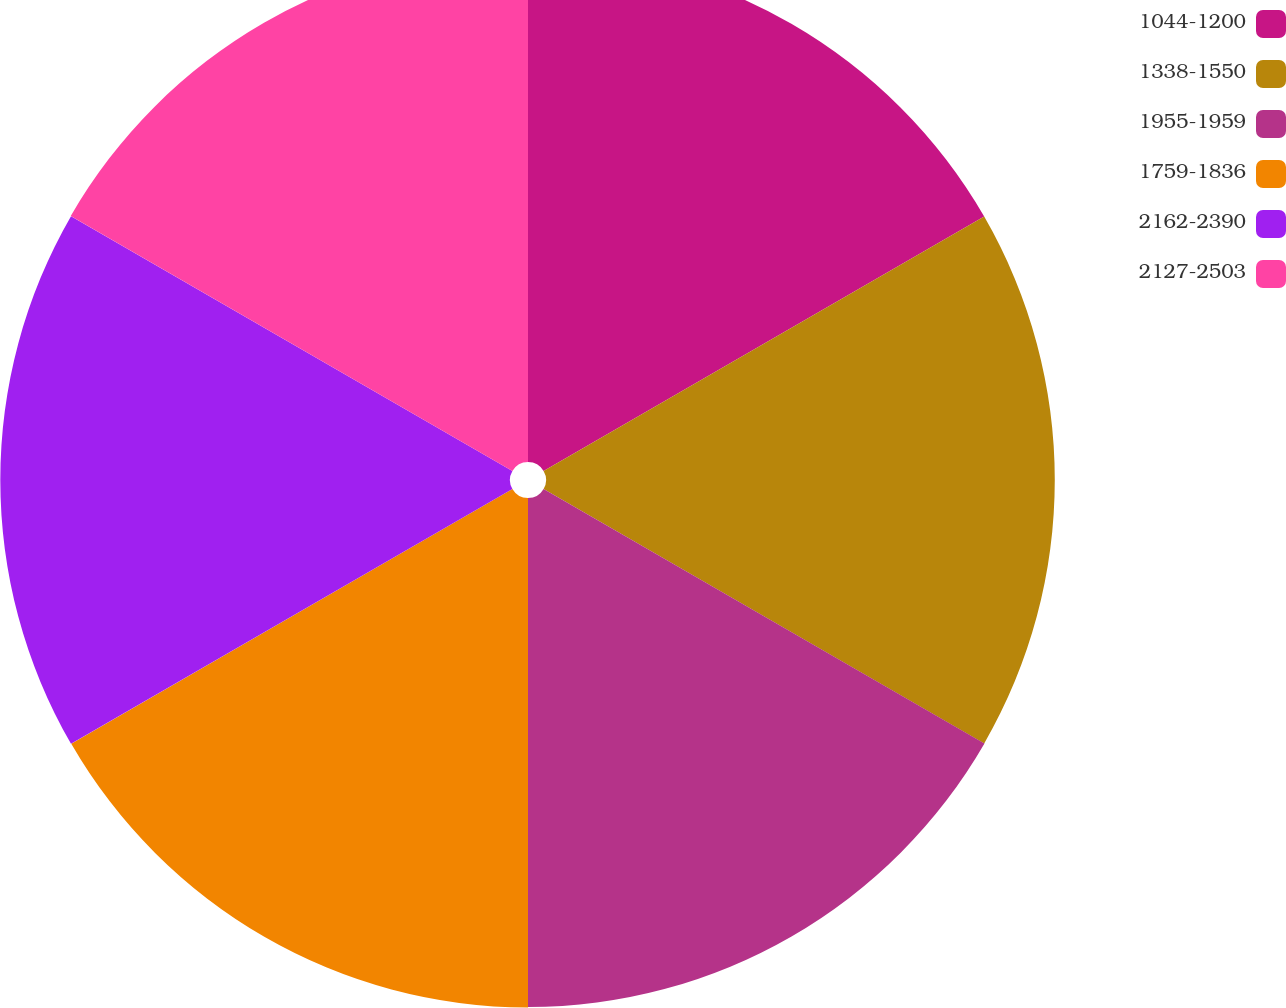Convert chart. <chart><loc_0><loc_0><loc_500><loc_500><pie_chart><fcel>1044-1200<fcel>1338-1550<fcel>1955-1959<fcel>1759-1836<fcel>2162-2390<fcel>2127-2503<nl><fcel>16.65%<fcel>16.65%<fcel>16.66%<fcel>16.67%<fcel>16.68%<fcel>16.69%<nl></chart> 